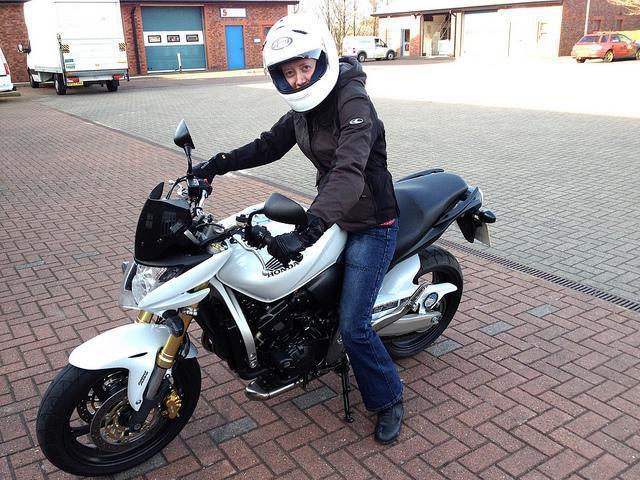How many motorcycles are there?
Give a very brief answer. 1. 